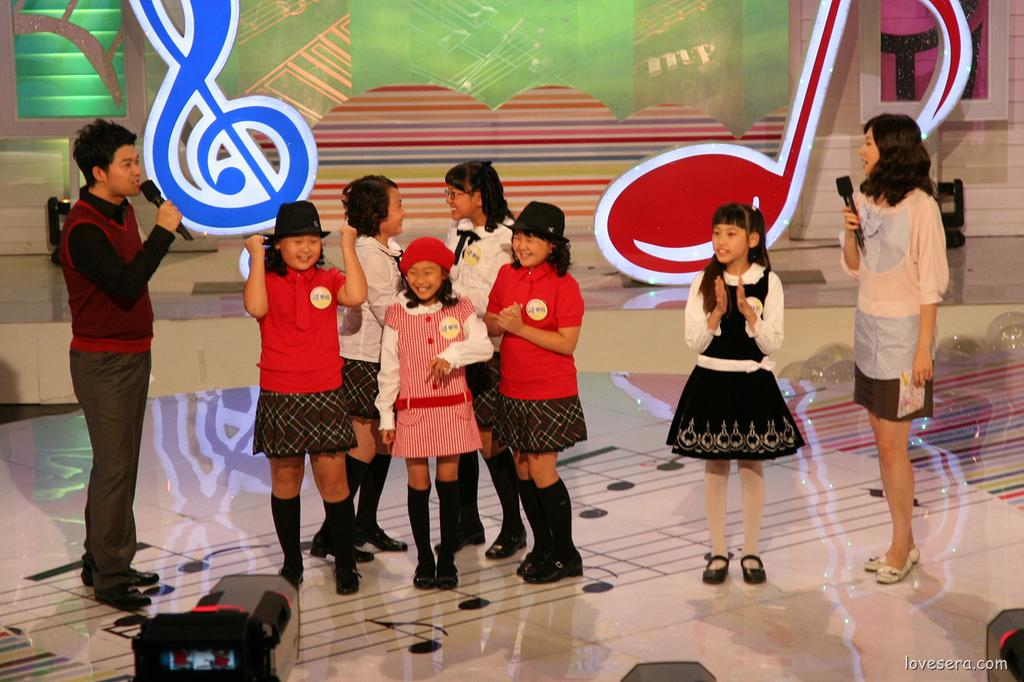What are the people in the center of the image doing? The people in the center of the image are standing. What objects are the lady and man holding in their hands? The lady and man are holding microphones in their hands. What can be seen in the background of the image? There are boards visible in the background of the image. What type of equipment is present at the bottom of the image? There are speakers at the bottom of the image. What type of digestion is the kitten performing in the image? There is no kitten present in the image, so it is not possible to determine what type of digestion might be occurring. 